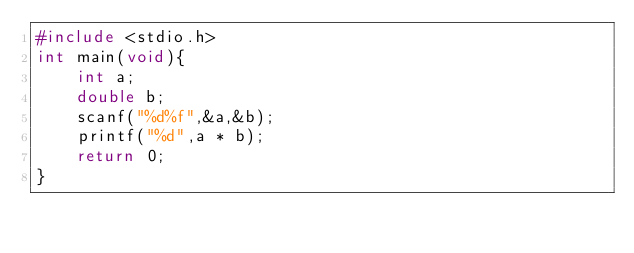<code> <loc_0><loc_0><loc_500><loc_500><_C_>#include <stdio.h>
int main(void){
    int a;
    double b;
    scanf("%d%f",&a,&b);
    printf("%d",a * b);
    return 0;
}</code> 